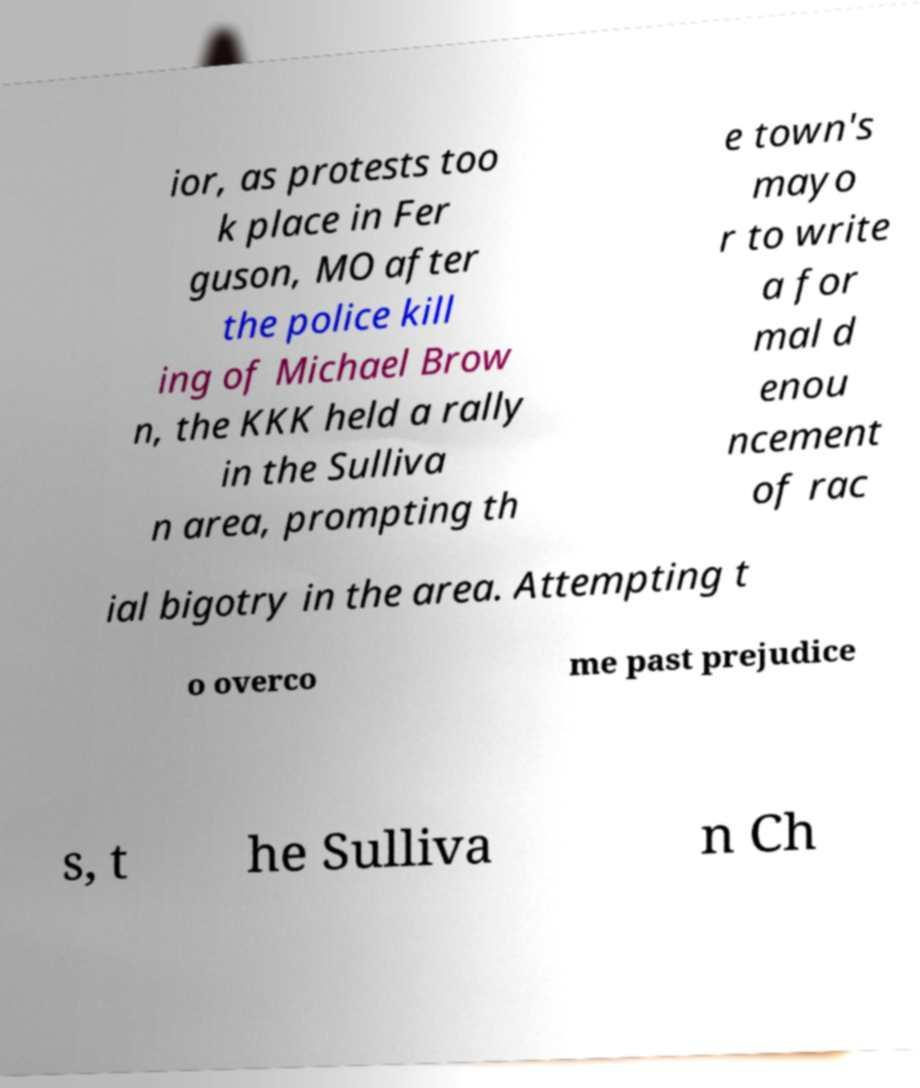Can you read and provide the text displayed in the image?This photo seems to have some interesting text. Can you extract and type it out for me? ior, as protests too k place in Fer guson, MO after the police kill ing of Michael Brow n, the KKK held a rally in the Sulliva n area, prompting th e town's mayo r to write a for mal d enou ncement of rac ial bigotry in the area. Attempting t o overco me past prejudice s, t he Sulliva n Ch 